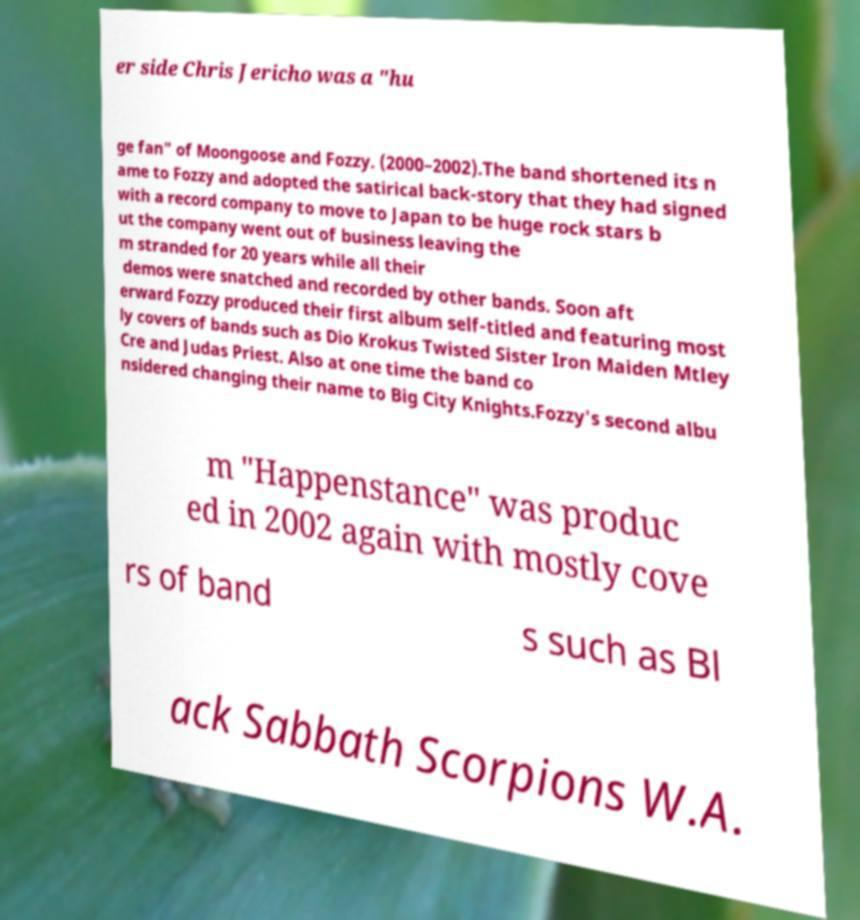Could you extract and type out the text from this image? er side Chris Jericho was a "hu ge fan" of Moongoose and Fozzy. (2000–2002).The band shortened its n ame to Fozzy and adopted the satirical back-story that they had signed with a record company to move to Japan to be huge rock stars b ut the company went out of business leaving the m stranded for 20 years while all their demos were snatched and recorded by other bands. Soon aft erward Fozzy produced their first album self-titled and featuring most ly covers of bands such as Dio Krokus Twisted Sister Iron Maiden Mtley Cre and Judas Priest. Also at one time the band co nsidered changing their name to Big City Knights.Fozzy's second albu m "Happenstance" was produc ed in 2002 again with mostly cove rs of band s such as Bl ack Sabbath Scorpions W.A. 